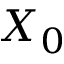Convert formula to latex. <formula><loc_0><loc_0><loc_500><loc_500>X _ { 0 }</formula> 